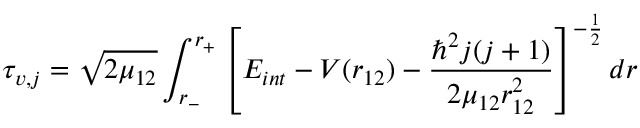Convert formula to latex. <formula><loc_0><loc_0><loc_500><loc_500>\tau _ { v , j } = \sqrt { 2 \mu _ { 1 2 } } \int _ { r _ { - } } ^ { r _ { + } } \left [ E _ { i n t } - V ( r _ { 1 2 } ) - \frac { \hbar { ^ } { 2 } j ( j + 1 ) } { 2 \mu _ { 1 2 } r _ { 1 2 } ^ { 2 } } \right ] ^ { - \frac { 1 } { 2 } } d r</formula> 